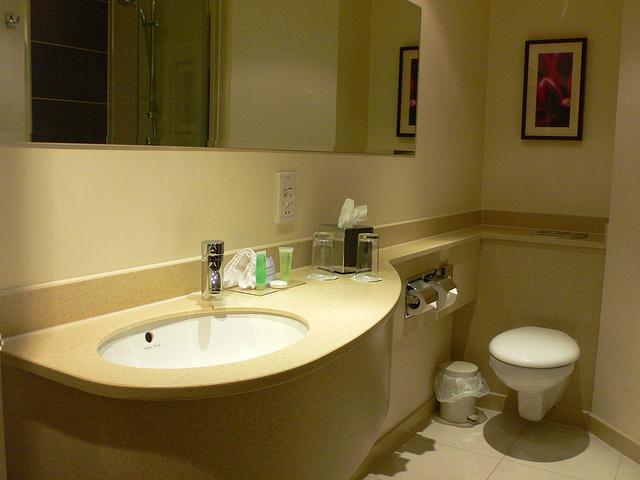Is this someone's home?
Concise answer only. Yes. How many glasses are there?
Keep it brief. 2. What type of room is this?
Short answer required. Bathroom. 